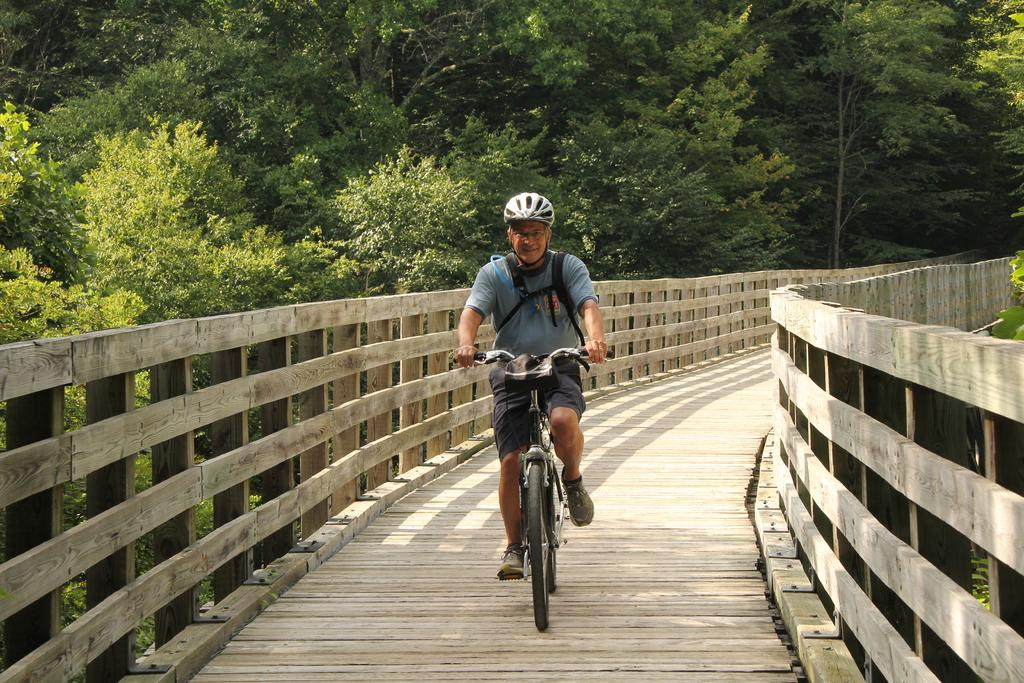What is the man in the image doing? The man is cycling in the image. Where is the man cycling? The man is cycling on a wooden bridge. What can be seen in the background of the image? There are trees in the background of the image. What is the man wearing that might be used for carrying items? The man is wearing a bag. What safety gear is the man wearing? The man is wearing a helmet. What type of pet can be seen walking alongside the man in the image? There is no pet present in the image; the man is cycling alone. What kind of oatmeal is being served on the wooden bridge in the image? There is no oatmeal present in the image; the man is cycling and there is no food mentioned in the facts. 